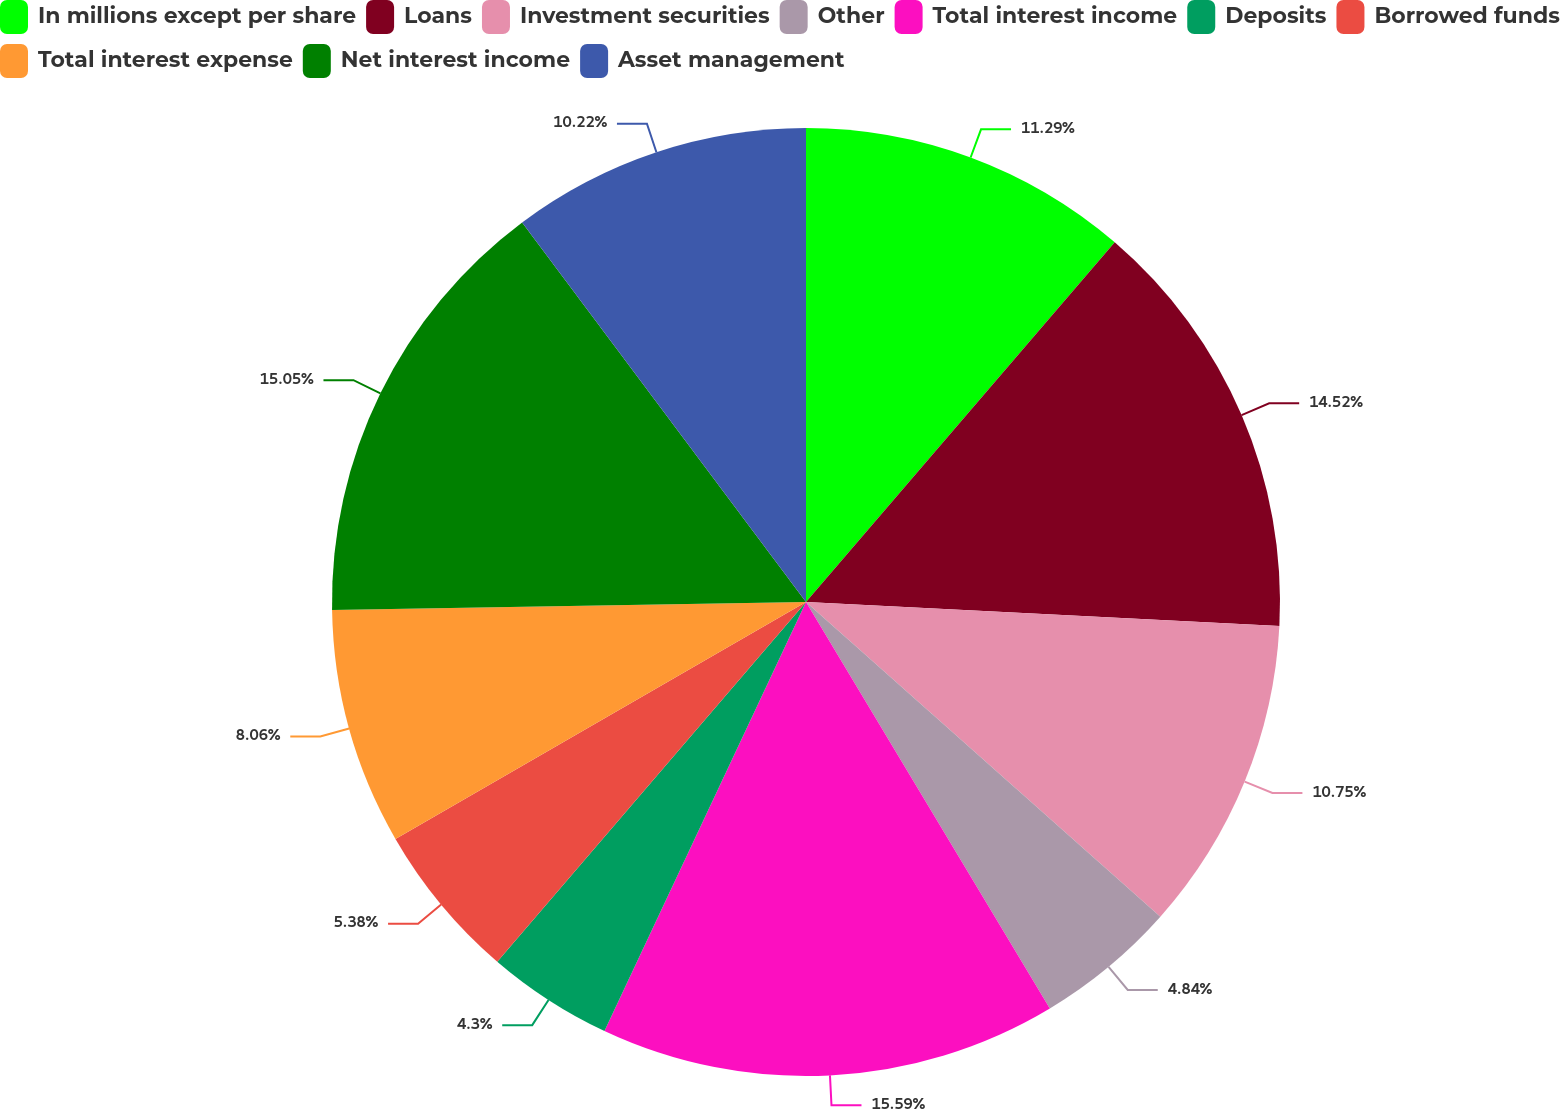Convert chart. <chart><loc_0><loc_0><loc_500><loc_500><pie_chart><fcel>In millions except per share<fcel>Loans<fcel>Investment securities<fcel>Other<fcel>Total interest income<fcel>Deposits<fcel>Borrowed funds<fcel>Total interest expense<fcel>Net interest income<fcel>Asset management<nl><fcel>11.29%<fcel>14.52%<fcel>10.75%<fcel>4.84%<fcel>15.59%<fcel>4.3%<fcel>5.38%<fcel>8.06%<fcel>15.05%<fcel>10.22%<nl></chart> 